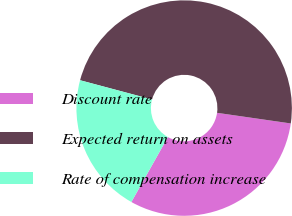Convert chart to OTSL. <chart><loc_0><loc_0><loc_500><loc_500><pie_chart><fcel>Discount rate<fcel>Expected return on assets<fcel>Rate of compensation increase<nl><fcel>30.87%<fcel>48.12%<fcel>21.01%<nl></chart> 